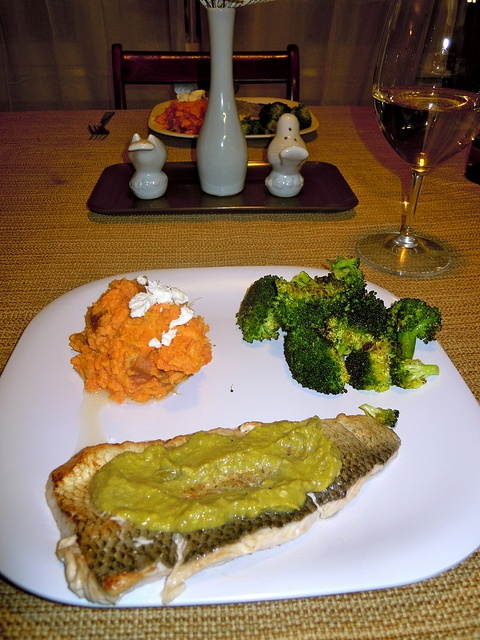Describe the objects in this image and their specific colors. I can see dining table in black, olive, maroon, and tan tones, wine glass in black, maroon, and olive tones, broccoli in black, darkgreen, and olive tones, chair in black, maroon, brown, and orange tones, and vase in black and gray tones in this image. 